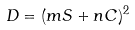Convert formula to latex. <formula><loc_0><loc_0><loc_500><loc_500>D = ( m S + n C ) ^ { 2 }</formula> 